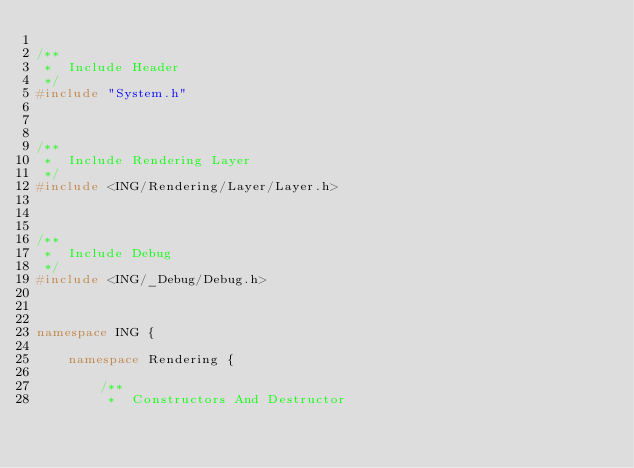<code> <loc_0><loc_0><loc_500><loc_500><_C++_>
/**
 *	Include Header
 */
#include "System.h"



/**
 *	Include Rendering Layer
 */
#include <ING/Rendering/Layer/Layer.h>



/**
 *	Include Debug
 */
#include <ING/_Debug/Debug.h>



namespace ING {

	namespace Rendering {

		/**
		 *	Constructors And Destructor</code> 